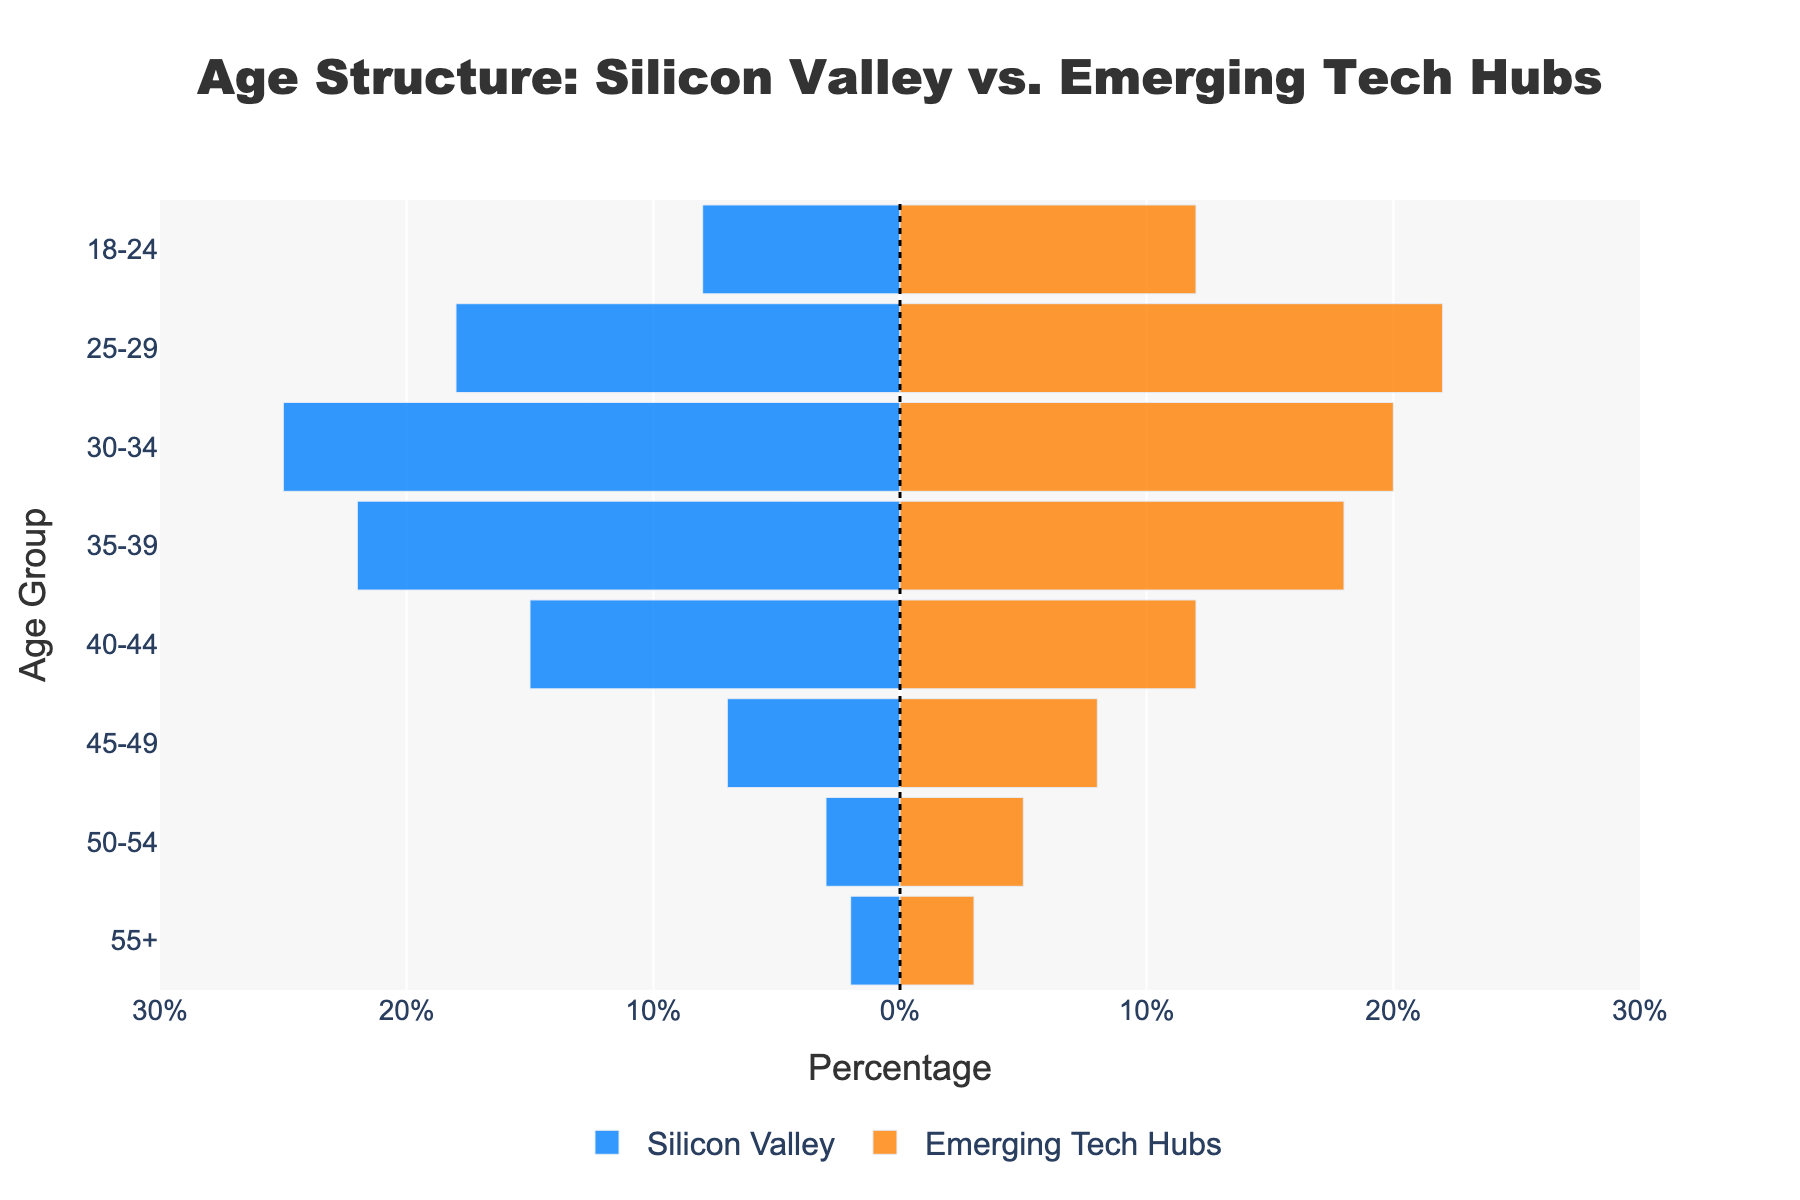What is the title of the figure? The title is usually displayed at the top of the figure and summarizes the content.
Answer: Age Structure: Silicon Valley vs. Emerging Tech Hubs How many age groups are defined in the figure? The age groups are listed along the y-axis of the figure. Count them to find the total number.
Answer: 8 Which age group has the highest percentage of employees in Silicon Valley? Look at the lengths of the bars on the left side of the zero line to determine which bar extends the furthest.
Answer: 30-34 What is the percentage of employees aged 25-29 in Emerging Tech Hubs? Identify the bar corresponding to the 25-29 age group on the right side and note its length.
Answer: 22% How does the percentage of employees aged 45-49 compare between Silicon Valley and Emerging Tech Hubs? Compare the lengths of the bars for the 45-49 age group on both sides of the zero line.
Answer: Emerging Tech Hubs have a slightly higher percentage (8% vs 7%) Which tech hub has more employees aged 55 and older? Compare the lengths of the bars for the 55+ age group. The longer bar indicates the hub with more employees.
Answer: Emerging Tech Hubs What is the overall trend in the age distribution for Silicon Valley? Observe the lengths of the bars from youngest to oldest age groups and describe the pattern.
Answer: Peaks at 30-34, then gradually decreases What is the total percentage of employees aged 18-34 in Emerging Tech Hubs? Sum the percentages for the age groups 18-24, 25-29, and 30-34 in Emerging Tech Hubs. 12% + 22% + 20% = 54%
Answer: 54% Is there a more balanced age distribution in Silicon Valley or Emerging Tech Hubs? Analyze the bars' lengths for both tech hubs to see which has a more even distribution across all age groups.
Answer: Emerging Tech Hubs What can you infer about the age structure of employees in the two tech hubs? Discuss the overall patterns observed in the plot, such as which age groups are more or less represented.
Answer: Silicon Valley has more mid-aged employees; Emerging Tech Hubs have more balanced age distribution 